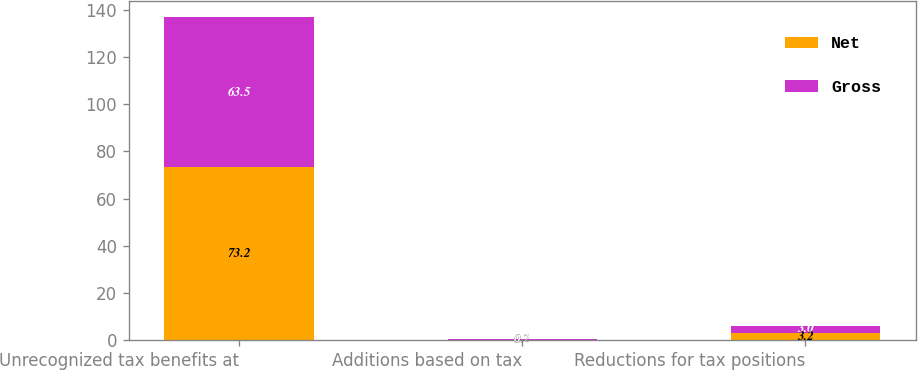<chart> <loc_0><loc_0><loc_500><loc_500><stacked_bar_chart><ecel><fcel>Unrecognized tax benefits at<fcel>Additions based on tax<fcel>Reductions for tax positions<nl><fcel>Net<fcel>73.2<fcel>0.2<fcel>3.2<nl><fcel>Gross<fcel>63.5<fcel>0.2<fcel>3<nl></chart> 